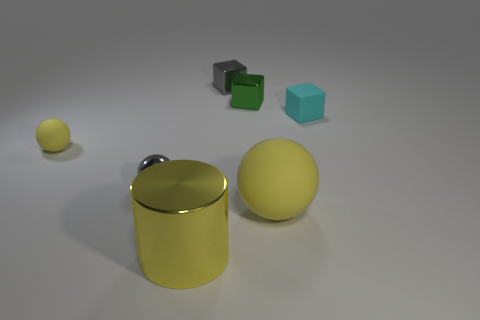Add 1 shiny blocks. How many objects exist? 8 Subtract all spheres. How many objects are left? 4 Add 1 small purple shiny things. How many small purple shiny things exist? 1 Subtract 0 blue cylinders. How many objects are left? 7 Subtract all small metallic things. Subtract all purple spheres. How many objects are left? 4 Add 2 tiny metal blocks. How many tiny metal blocks are left? 4 